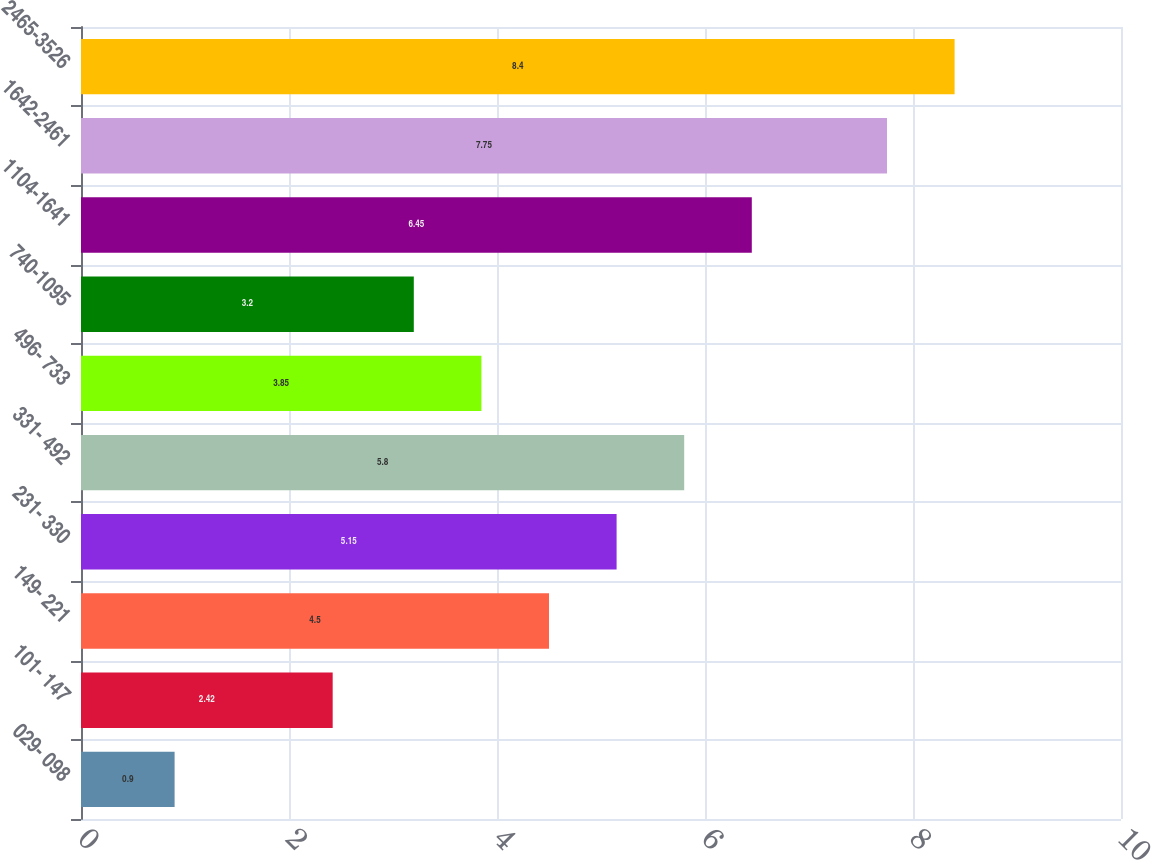Convert chart. <chart><loc_0><loc_0><loc_500><loc_500><bar_chart><fcel>029- 098<fcel>101- 147<fcel>149- 221<fcel>231- 330<fcel>331- 492<fcel>496- 733<fcel>740-1095<fcel>1104-1641<fcel>1642-2461<fcel>2465-3526<nl><fcel>0.9<fcel>2.42<fcel>4.5<fcel>5.15<fcel>5.8<fcel>3.85<fcel>3.2<fcel>6.45<fcel>7.75<fcel>8.4<nl></chart> 